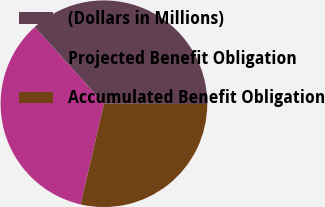Convert chart to OTSL. <chart><loc_0><loc_0><loc_500><loc_500><pie_chart><fcel>(Dollars in Millions)<fcel>Projected Benefit Obligation<fcel>Accumulated Benefit Obligation<nl><fcel>36.73%<fcel>34.71%<fcel>28.57%<nl></chart> 